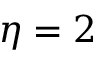Convert formula to latex. <formula><loc_0><loc_0><loc_500><loc_500>\eta = 2</formula> 